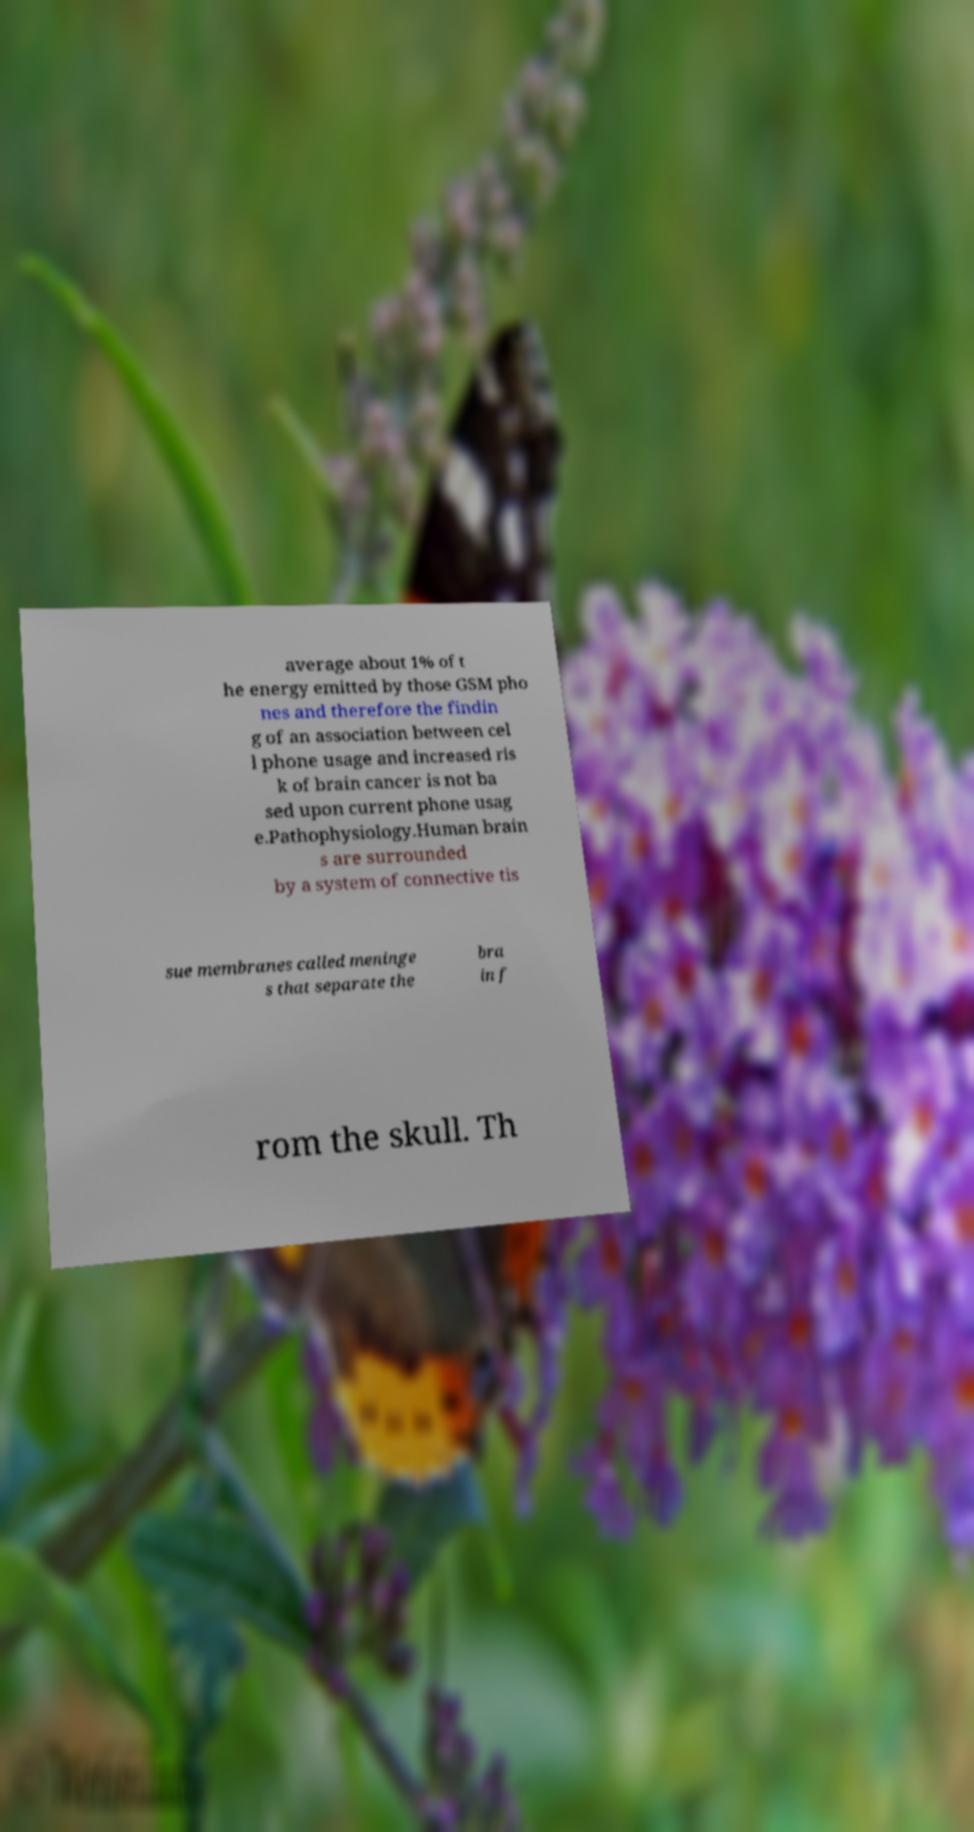Can you accurately transcribe the text from the provided image for me? average about 1% of t he energy emitted by those GSM pho nes and therefore the findin g of an association between cel l phone usage and increased ris k of brain cancer is not ba sed upon current phone usag e.Pathophysiology.Human brain s are surrounded by a system of connective tis sue membranes called meninge s that separate the bra in f rom the skull. Th 